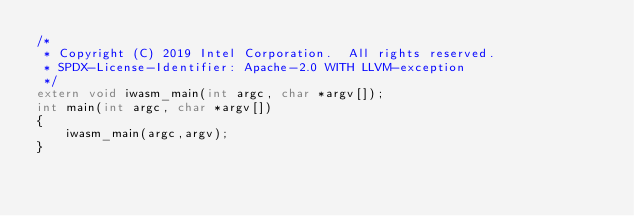Convert code to text. <code><loc_0><loc_0><loc_500><loc_500><_C_>/*
 * Copyright (C) 2019 Intel Corporation.  All rights reserved.
 * SPDX-License-Identifier: Apache-2.0 WITH LLVM-exception
 */
extern void iwasm_main(int argc, char *argv[]);
int main(int argc, char *argv[])
{
    iwasm_main(argc,argv);
}
</code> 